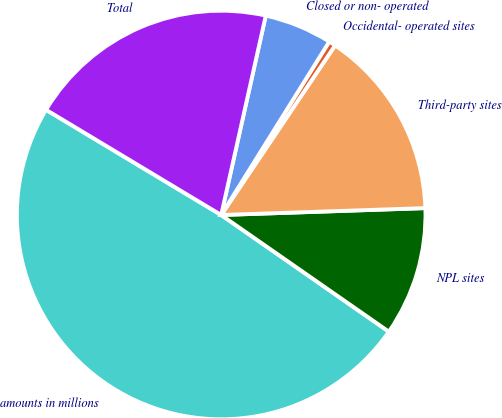<chart> <loc_0><loc_0><loc_500><loc_500><pie_chart><fcel>amounts in millions<fcel>NPL sites<fcel>Third-party sites<fcel>Occidental- operated sites<fcel>Closed or non- operated<fcel>Total<nl><fcel>48.93%<fcel>10.21%<fcel>15.05%<fcel>0.54%<fcel>5.37%<fcel>19.89%<nl></chart> 